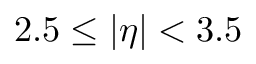<formula> <loc_0><loc_0><loc_500><loc_500>2 . 5 \leq | \eta | < 3 . 5</formula> 